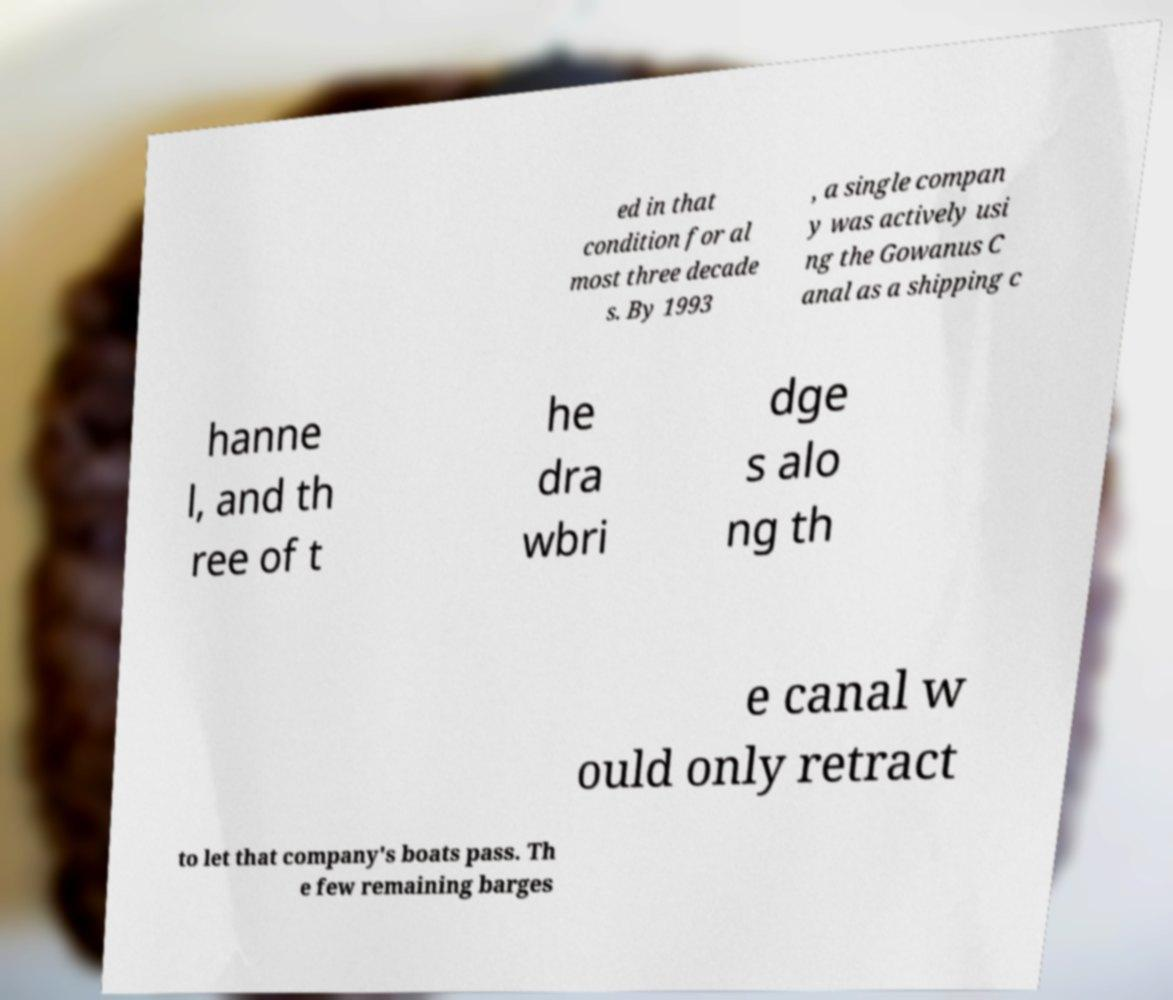Could you extract and type out the text from this image? ed in that condition for al most three decade s. By 1993 , a single compan y was actively usi ng the Gowanus C anal as a shipping c hanne l, and th ree of t he dra wbri dge s alo ng th e canal w ould only retract to let that company's boats pass. Th e few remaining barges 